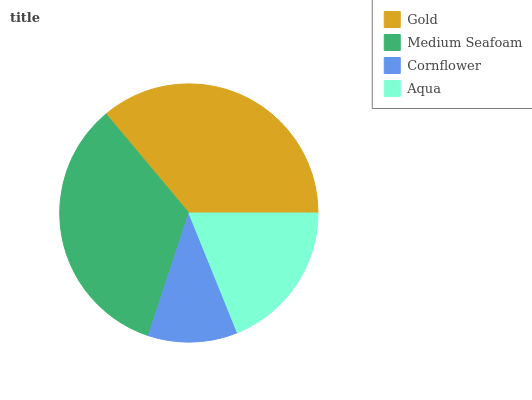Is Cornflower the minimum?
Answer yes or no. Yes. Is Gold the maximum?
Answer yes or no. Yes. Is Medium Seafoam the minimum?
Answer yes or no. No. Is Medium Seafoam the maximum?
Answer yes or no. No. Is Gold greater than Medium Seafoam?
Answer yes or no. Yes. Is Medium Seafoam less than Gold?
Answer yes or no. Yes. Is Medium Seafoam greater than Gold?
Answer yes or no. No. Is Gold less than Medium Seafoam?
Answer yes or no. No. Is Medium Seafoam the high median?
Answer yes or no. Yes. Is Aqua the low median?
Answer yes or no. Yes. Is Gold the high median?
Answer yes or no. No. Is Gold the low median?
Answer yes or no. No. 